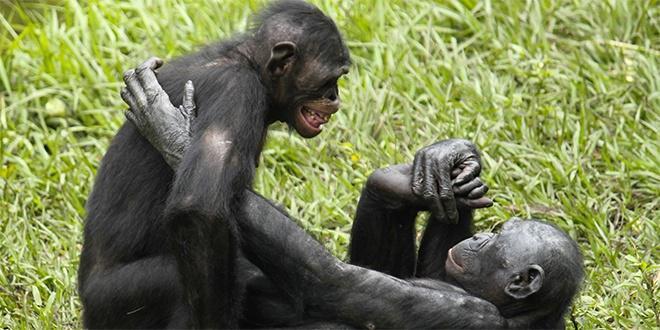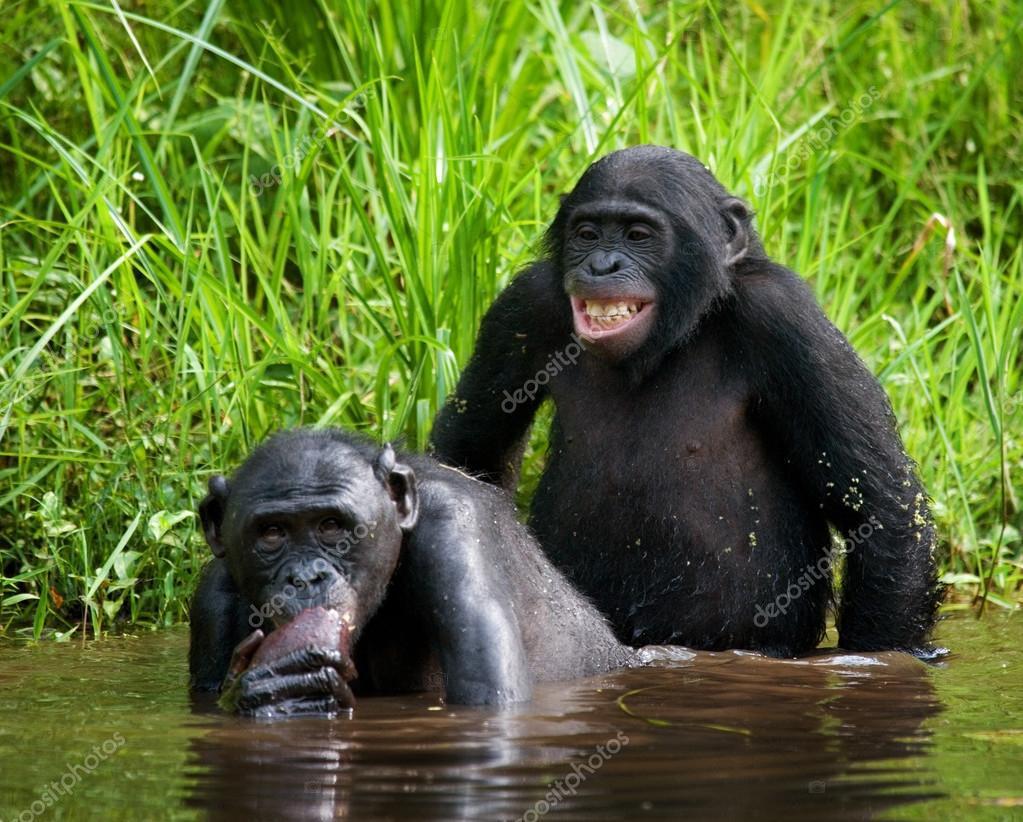The first image is the image on the left, the second image is the image on the right. Examine the images to the left and right. Is the description "At least one of the monkeys is a baby." accurate? Answer yes or no. No. The first image is the image on the left, the second image is the image on the right. Examine the images to the left and right. Is the description "there is a mother chimp holding her infant" accurate? Answer yes or no. No. 